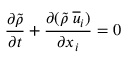Convert formula to latex. <formula><loc_0><loc_0><loc_500><loc_500>\frac { \partial \tilde { \rho } } { \partial t } + \frac { \partial ( \tilde { \rho } \, \overline { u } _ { i } ) } { \partial x _ { i } } = 0</formula> 